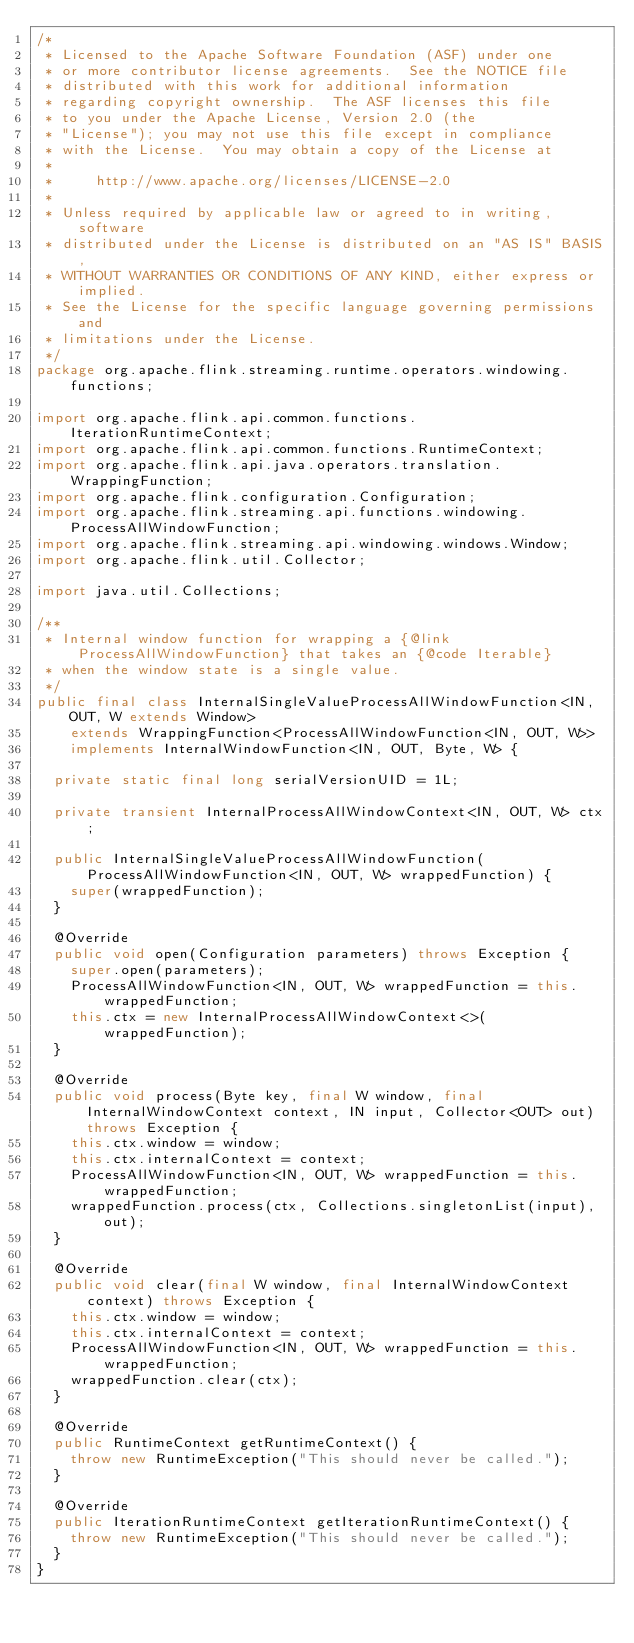Convert code to text. <code><loc_0><loc_0><loc_500><loc_500><_Java_>/*
 * Licensed to the Apache Software Foundation (ASF) under one
 * or more contributor license agreements.  See the NOTICE file
 * distributed with this work for additional information
 * regarding copyright ownership.  The ASF licenses this file
 * to you under the Apache License, Version 2.0 (the
 * "License"); you may not use this file except in compliance
 * with the License.  You may obtain a copy of the License at
 *
 *     http://www.apache.org/licenses/LICENSE-2.0
 *
 * Unless required by applicable law or agreed to in writing, software
 * distributed under the License is distributed on an "AS IS" BASIS,
 * WITHOUT WARRANTIES OR CONDITIONS OF ANY KIND, either express or implied.
 * See the License for the specific language governing permissions and
 * limitations under the License.
 */
package org.apache.flink.streaming.runtime.operators.windowing.functions;

import org.apache.flink.api.common.functions.IterationRuntimeContext;
import org.apache.flink.api.common.functions.RuntimeContext;
import org.apache.flink.api.java.operators.translation.WrappingFunction;
import org.apache.flink.configuration.Configuration;
import org.apache.flink.streaming.api.functions.windowing.ProcessAllWindowFunction;
import org.apache.flink.streaming.api.windowing.windows.Window;
import org.apache.flink.util.Collector;

import java.util.Collections;

/**
 * Internal window function for wrapping a {@link ProcessAllWindowFunction} that takes an {@code Iterable}
 * when the window state is a single value.
 */
public final class InternalSingleValueProcessAllWindowFunction<IN, OUT, W extends Window>
		extends WrappingFunction<ProcessAllWindowFunction<IN, OUT, W>>
		implements InternalWindowFunction<IN, OUT, Byte, W> {

	private static final long serialVersionUID = 1L;

	private transient InternalProcessAllWindowContext<IN, OUT, W> ctx;

	public InternalSingleValueProcessAllWindowFunction(ProcessAllWindowFunction<IN, OUT, W> wrappedFunction) {
		super(wrappedFunction);
	}

	@Override
	public void open(Configuration parameters) throws Exception {
		super.open(parameters);
		ProcessAllWindowFunction<IN, OUT, W> wrappedFunction = this.wrappedFunction;
		this.ctx = new InternalProcessAllWindowContext<>(wrappedFunction);
	}

	@Override
	public void process(Byte key, final W window, final InternalWindowContext context, IN input, Collector<OUT> out) throws Exception {
		this.ctx.window = window;
		this.ctx.internalContext = context;
		ProcessAllWindowFunction<IN, OUT, W> wrappedFunction = this.wrappedFunction;
		wrappedFunction.process(ctx, Collections.singletonList(input), out);
	}

	@Override
	public void clear(final W window, final InternalWindowContext context) throws Exception {
		this.ctx.window = window;
		this.ctx.internalContext = context;
		ProcessAllWindowFunction<IN, OUT, W> wrappedFunction = this.wrappedFunction;
		wrappedFunction.clear(ctx);
	}

	@Override
	public RuntimeContext getRuntimeContext() {
		throw new RuntimeException("This should never be called.");
	}

	@Override
	public IterationRuntimeContext getIterationRuntimeContext() {
		throw new RuntimeException("This should never be called.");
	}
}
</code> 